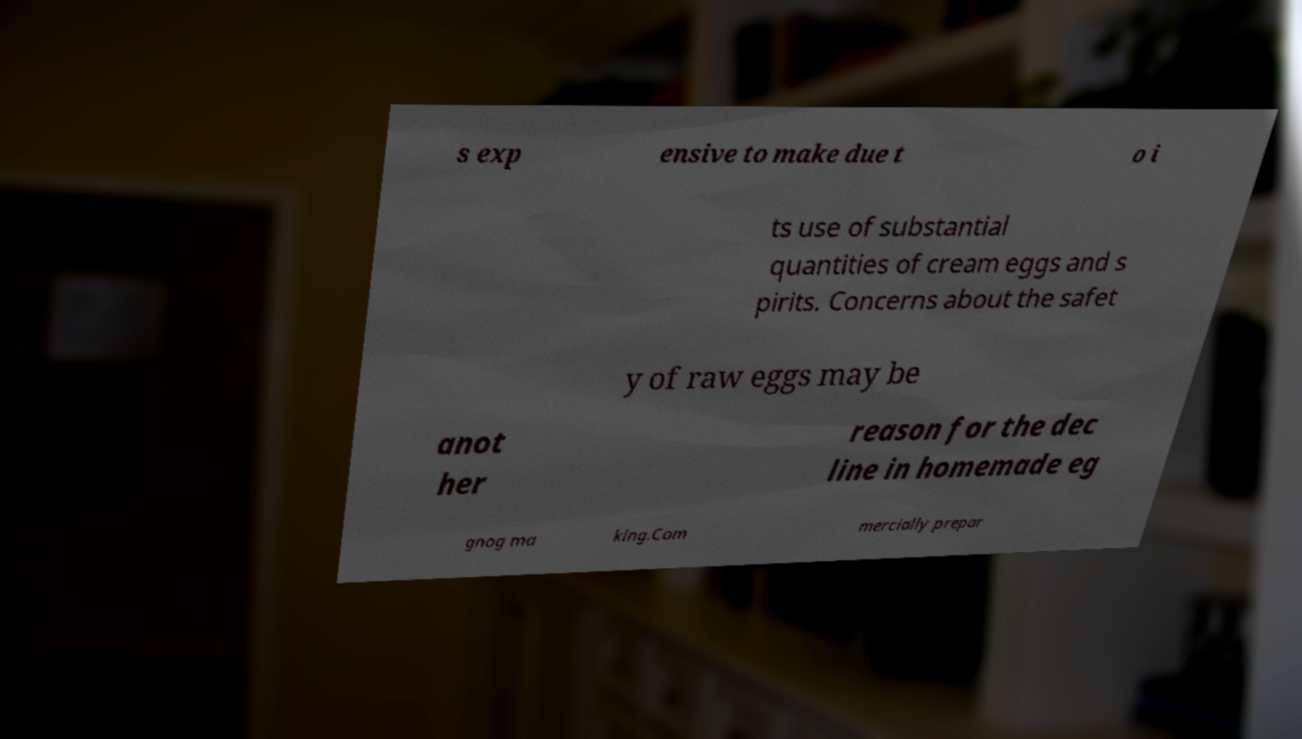Could you extract and type out the text from this image? s exp ensive to make due t o i ts use of substantial quantities of cream eggs and s pirits. Concerns about the safet y of raw eggs may be anot her reason for the dec line in homemade eg gnog ma king.Com mercially prepar 